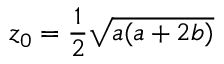<formula> <loc_0><loc_0><loc_500><loc_500>z _ { 0 } = \frac { 1 } { 2 } \sqrt { a ( a + 2 b ) }</formula> 